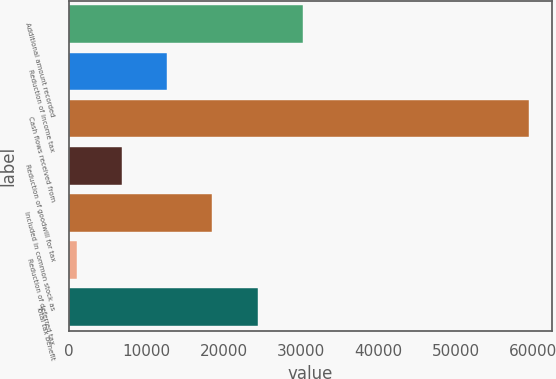<chart> <loc_0><loc_0><loc_500><loc_500><bar_chart><fcel>Additional amount recorded<fcel>Reduction of income tax<fcel>Cash flows received from<fcel>Reduction of goodwill for tax<fcel>Included in common stock as<fcel>Reduction of deferred tax<fcel>Total tax benefit<nl><fcel>30255.5<fcel>12725<fcel>59473<fcel>6881.5<fcel>18568.5<fcel>1038<fcel>24412<nl></chart> 